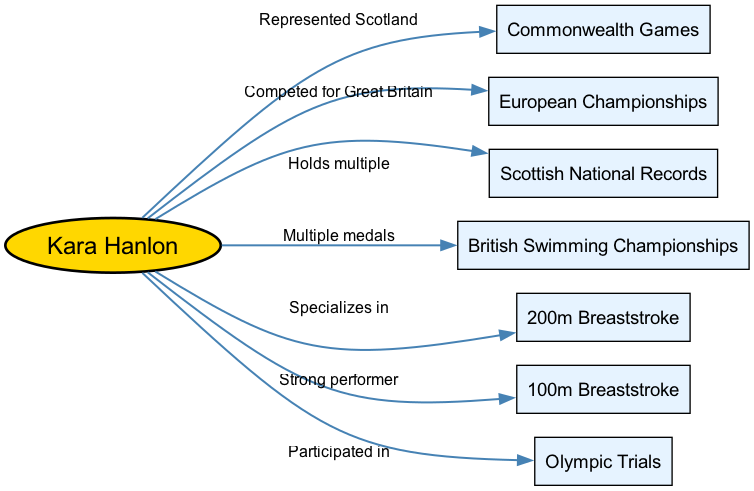What major competitions has Kara Hanlon represented Scotland in? The diagram indicates that Kara Hanlon represented Scotland in the Commonwealth Games. This is a key node directly connected to her as the central node.
Answer: Commonwealth Games How many Scottish National Records does Kara Hanlon hold? The diagram illustrates that Kara Hanlon holds multiple Scottish National Records. This information is conveyed directly by the connection labeled "Holds multiple" from her to the Scottish National Records node.
Answer: Multiple Which stroke does Kara Hanlon specialize in? The diagram specifies that Kara Hanlon specializes in the 200m Breaststroke, indicated by the connection labeled "Specializes in." This is a direct relationship from her central node to the 200m Breaststroke node.
Answer: 200m Breaststroke In what events did Kara Hanlon participate at the Olympic Trials? The diagram indicates that Kara Hanlon participated in the Olympic Trials without specifying the number of events or details, as it only shows a connection labeled "Participated in" from her to the Olympic Trials node.
Answer: Olympic Trials What type of records does Kara Hanlon hold? The diagram shows that Kara Hanlon holds records relating to being a part of Scottish National Records, as indicated by the connection labeled "Holds multiple." This highlights her achievements in this area.
Answer: Scottish National Records In which championships has Kara Hanlon won multiple medals? The diagram notes that Kara Hanlon has won multiple medals at the British Swimming Championships. This is represented by the connection labeled "Multiple medals" leading to that node from her central position.
Answer: British Swimming Championships What kind of performer is Kara Hanlon in the 100m Breaststroke? The diagram states that Kara Hanlon is a strong performer in the 100m Breaststroke, indicated by the connection labeled "Strong performer" from her to that node.
Answer: Strong performer For which country did Kara Hanlon compete in the European Championships? The diagram shows that Kara Hanlon competed for Great Britain in the European Championships, as established by the connection labeled "Competed for Great Britain."
Answer: Great Britain What are the two breaststroke events in which Kara Hanlon is active? The diagram outlines that Kara Hanlon is active in the 100m and 200m Breaststroke events, as indicated by the specific connections labeled "Strong performer" and "Specializes in" that relate these events to her central node.
Answer: 100m Breaststroke and 200m Breaststroke 